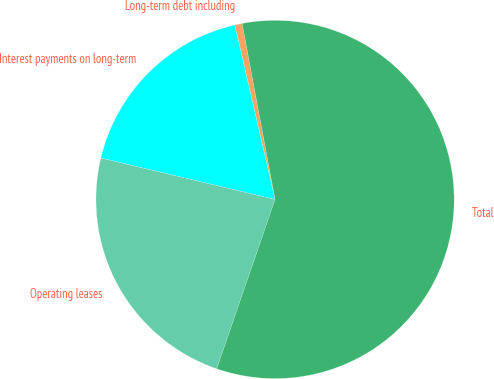<chart> <loc_0><loc_0><loc_500><loc_500><pie_chart><fcel>Long-term debt including<fcel>Interest payments on long-term<fcel>Operating leases<fcel>Total<nl><fcel>0.67%<fcel>17.67%<fcel>23.43%<fcel>58.22%<nl></chart> 